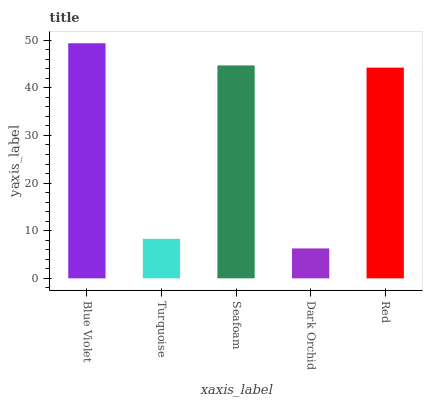Is Dark Orchid the minimum?
Answer yes or no. Yes. Is Blue Violet the maximum?
Answer yes or no. Yes. Is Turquoise the minimum?
Answer yes or no. No. Is Turquoise the maximum?
Answer yes or no. No. Is Blue Violet greater than Turquoise?
Answer yes or no. Yes. Is Turquoise less than Blue Violet?
Answer yes or no. Yes. Is Turquoise greater than Blue Violet?
Answer yes or no. No. Is Blue Violet less than Turquoise?
Answer yes or no. No. Is Red the high median?
Answer yes or no. Yes. Is Red the low median?
Answer yes or no. Yes. Is Blue Violet the high median?
Answer yes or no. No. Is Dark Orchid the low median?
Answer yes or no. No. 